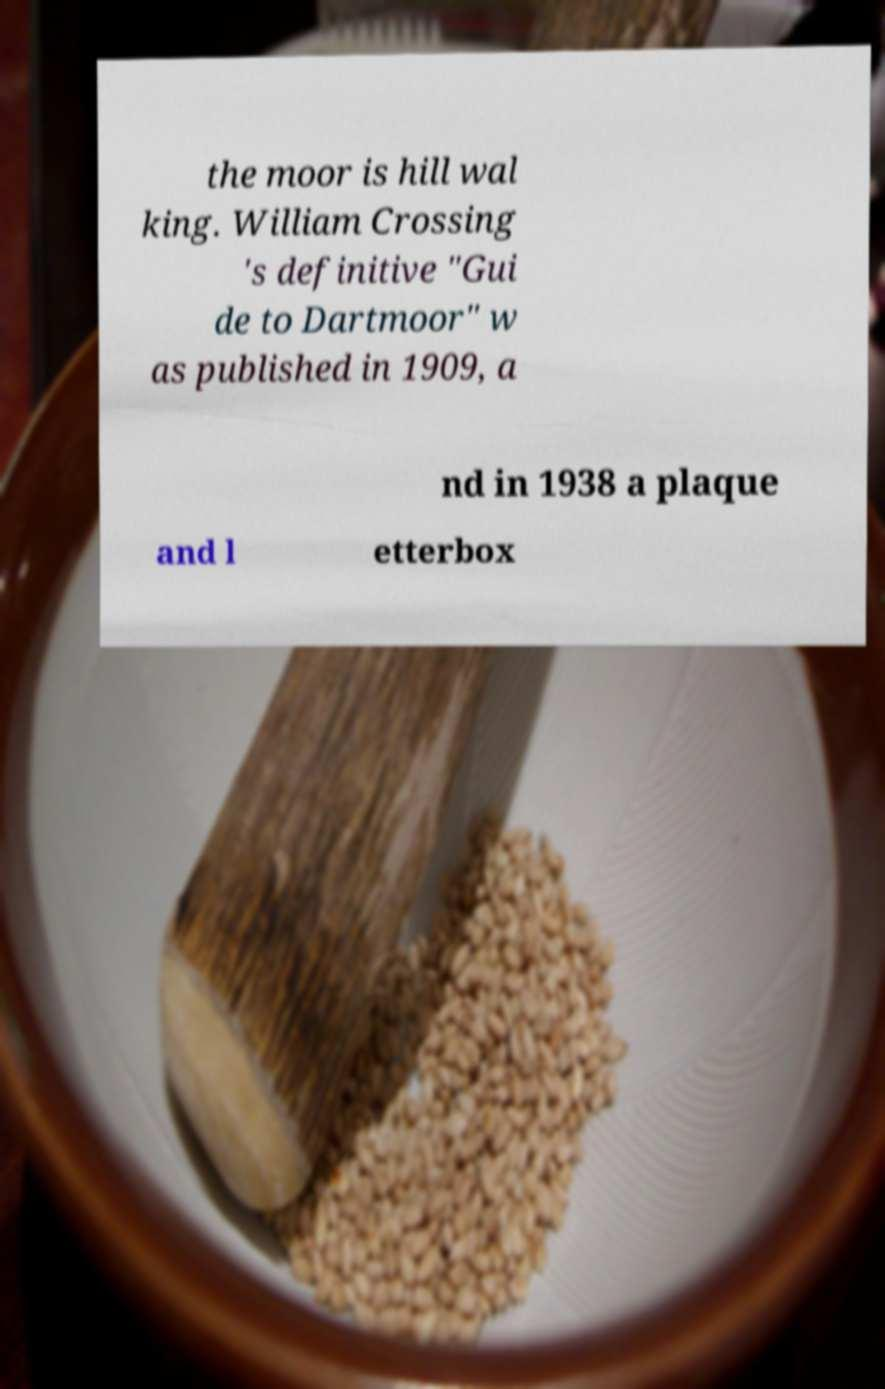There's text embedded in this image that I need extracted. Can you transcribe it verbatim? the moor is hill wal king. William Crossing 's definitive "Gui de to Dartmoor" w as published in 1909, a nd in 1938 a plaque and l etterbox 